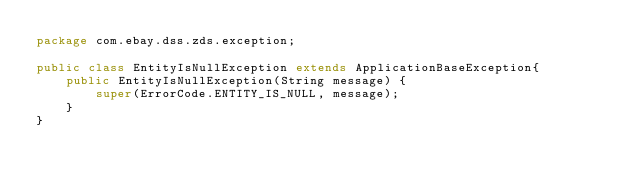<code> <loc_0><loc_0><loc_500><loc_500><_Java_>package com.ebay.dss.zds.exception;

public class EntityIsNullException extends ApplicationBaseException{
    public EntityIsNullException(String message) {
        super(ErrorCode.ENTITY_IS_NULL, message);
    }
}
</code> 